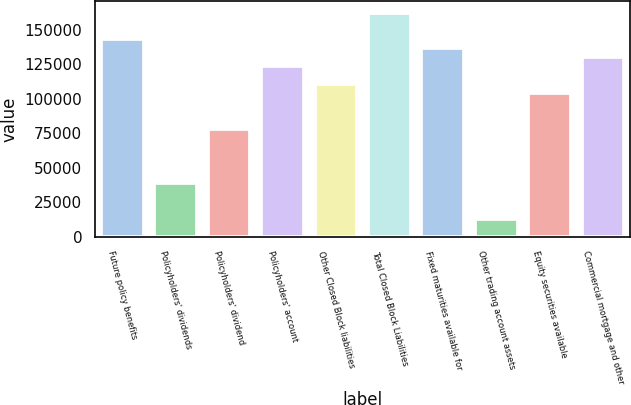Convert chart to OTSL. <chart><loc_0><loc_0><loc_500><loc_500><bar_chart><fcel>Future policy benefits<fcel>Policyholders' dividends<fcel>Policyholders' dividend<fcel>Policyholders' account<fcel>Other Closed Block liabilities<fcel>Total Closed Block Liabilities<fcel>Fixed maturities available for<fcel>Other trading account assets<fcel>Equity securities available<fcel>Commercial mortgage and other<nl><fcel>142905<fcel>38974.5<fcel>77948.3<fcel>123418<fcel>110427<fcel>162392<fcel>136409<fcel>12991.9<fcel>103931<fcel>129913<nl></chart> 